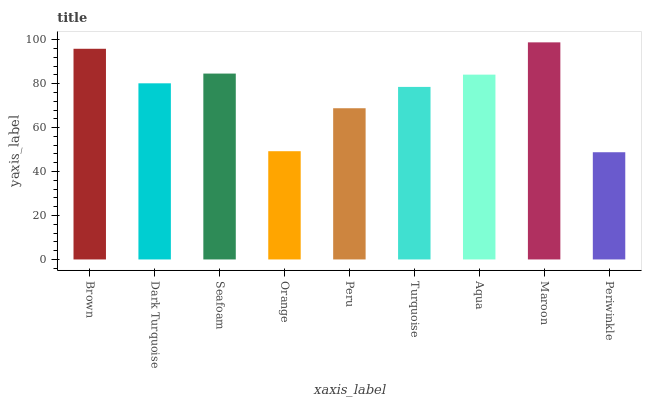Is Dark Turquoise the minimum?
Answer yes or no. No. Is Dark Turquoise the maximum?
Answer yes or no. No. Is Brown greater than Dark Turquoise?
Answer yes or no. Yes. Is Dark Turquoise less than Brown?
Answer yes or no. Yes. Is Dark Turquoise greater than Brown?
Answer yes or no. No. Is Brown less than Dark Turquoise?
Answer yes or no. No. Is Dark Turquoise the high median?
Answer yes or no. Yes. Is Dark Turquoise the low median?
Answer yes or no. Yes. Is Periwinkle the high median?
Answer yes or no. No. Is Brown the low median?
Answer yes or no. No. 